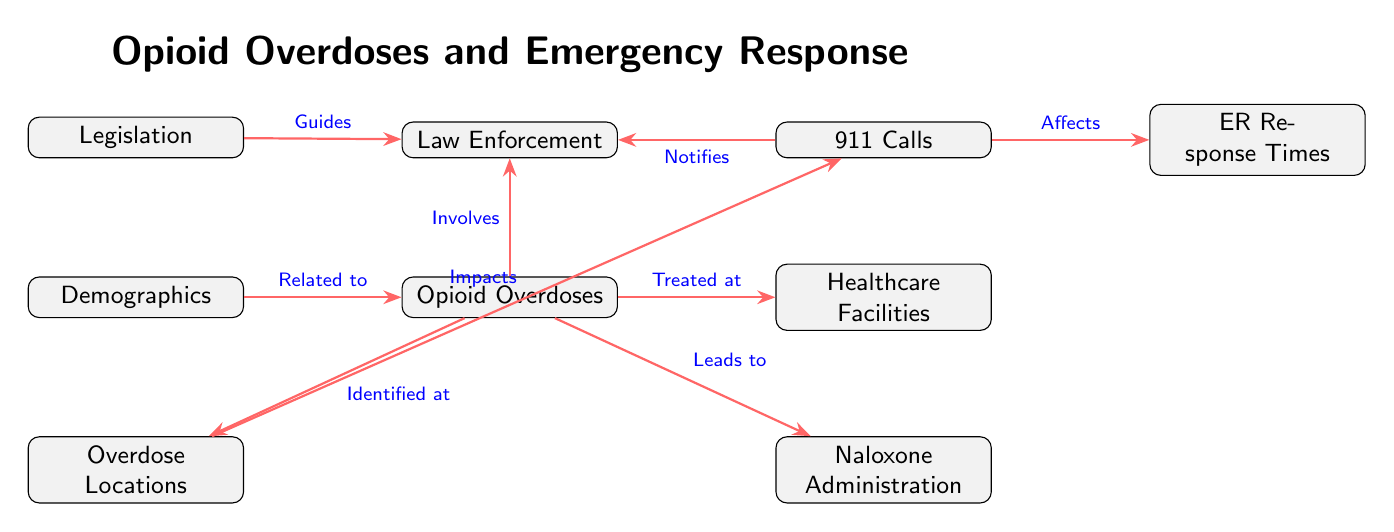What are the two main outcomes of opioid overdoses in the diagram? The diagram shows that the two main outcomes of opioid overdoses are "Naloxone Administration" and "Treated at Healthcare Facilities." These are represented as nodes directly connected to the "Opioid Overdoses" node, indicating they are the primary responses to such incidents.
Answer: Naloxone Administration, Treated at Healthcare Facilities Which node is directly impacted by overdose locations? The diagram indicates that "911 Calls" is the node that is impacted by "Overdose Locations." The arrow labeled "Impacts" shows this direct influence in the flow of the diagram.
Answer: 911 Calls How many nodes are represented in the diagram? A count of all the unique nodes listed in the diagram shows there are a total of eight nodes: Opioid Overdoses, 911 Calls, ER Response Times, Naloxone Administration, Overdose Locations, Demographics, Legislation, Law Enforcement, and Healthcare Facilities.
Answer: 8 What does the arrow from 911 Calls to ER Response Times indicate? The arrow labeled "Affects" from "911 Calls" to "ER Response Times" indicates a causal relationship where the number of 911 Calls influences or affects how long it takes for emergency responders to arrive at the scene, suggesting that more calls may lead to longer or variable response times.
Answer: Affects Which element guides law enforcement according to the diagram? The diagram shows that "Legislation" is the element that guides "Law Enforcement." The arrow labeled "Guides" connects these nodes, illustrating the influence of legislative measures on law enforcement actions regarding opioid overdoses.
Answer: Legislation What is the relationship between opioid overdoses and demographics? The relationship indicated in the diagram shows that "Demographics" is "Related to" "Opioid Overdoses," suggesting that demographic factors may influence the incidence or characteristics of opioid overdoses in a given population.
Answer: Related to How do overdose locations influence 911 calls? The arrow labeled "Impacts" shows the direct influence that "Overdose Locations" have on "911 Calls." This means that specific locations where overdoses are prevalent can affect the frequency or urgency of calls made to emergency services from those areas.
Answer: Impacts 